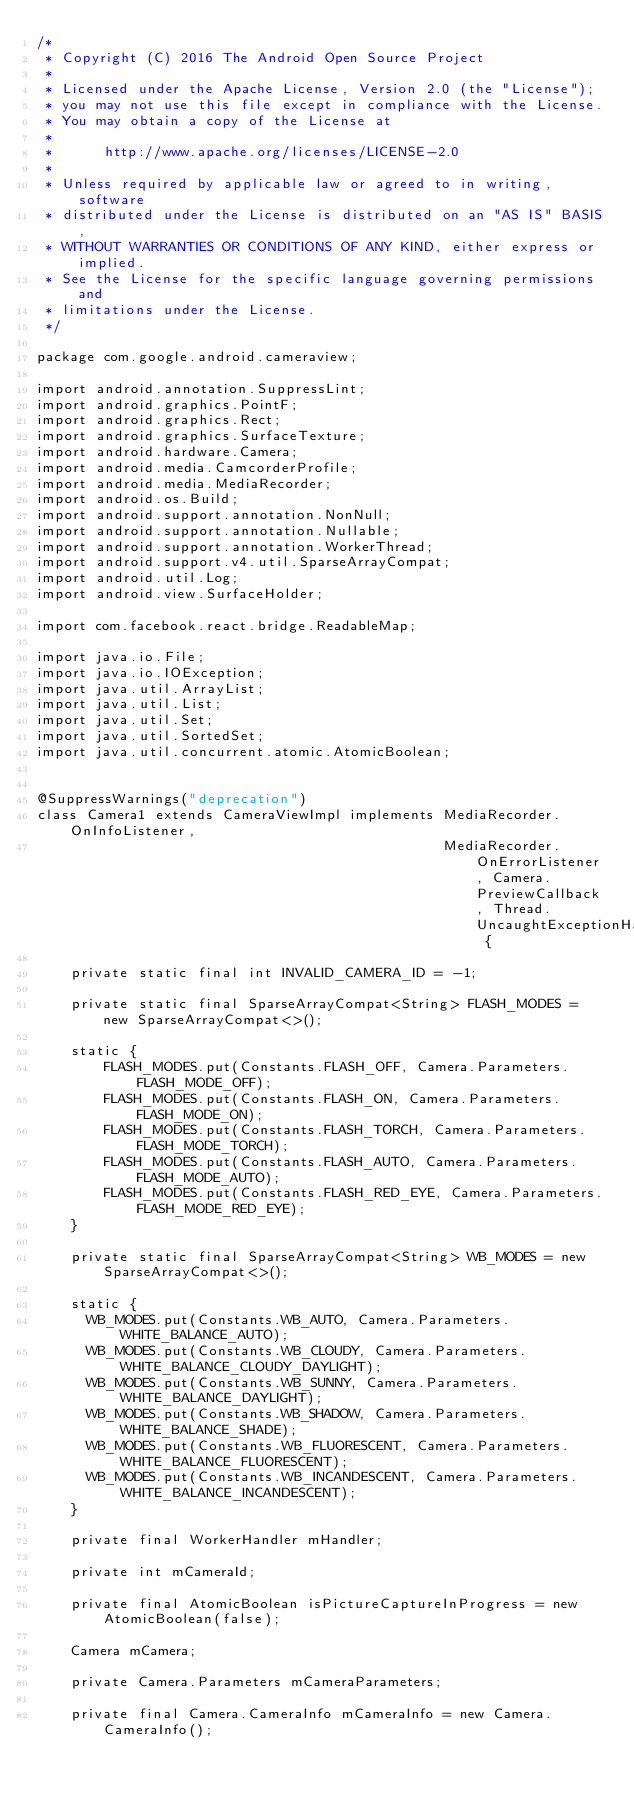<code> <loc_0><loc_0><loc_500><loc_500><_Java_>/*
 * Copyright (C) 2016 The Android Open Source Project
 *
 * Licensed under the Apache License, Version 2.0 (the "License");
 * you may not use this file except in compliance with the License.
 * You may obtain a copy of the License at
 *
 *      http://www.apache.org/licenses/LICENSE-2.0
 *
 * Unless required by applicable law or agreed to in writing, software
 * distributed under the License is distributed on an "AS IS" BASIS,
 * WITHOUT WARRANTIES OR CONDITIONS OF ANY KIND, either express or implied.
 * See the License for the specific language governing permissions and
 * limitations under the License.
 */

package com.google.android.cameraview;

import android.annotation.SuppressLint;
import android.graphics.PointF;
import android.graphics.Rect;
import android.graphics.SurfaceTexture;
import android.hardware.Camera;
import android.media.CamcorderProfile;
import android.media.MediaRecorder;
import android.os.Build;
import android.support.annotation.NonNull;
import android.support.annotation.Nullable;
import android.support.annotation.WorkerThread;
import android.support.v4.util.SparseArrayCompat;
import android.util.Log;
import android.view.SurfaceHolder;

import com.facebook.react.bridge.ReadableMap;

import java.io.File;
import java.io.IOException;
import java.util.ArrayList;
import java.util.List;
import java.util.Set;
import java.util.SortedSet;
import java.util.concurrent.atomic.AtomicBoolean;


@SuppressWarnings("deprecation")
class Camera1 extends CameraViewImpl implements MediaRecorder.OnInfoListener,
                                                MediaRecorder.OnErrorListener, Camera.PreviewCallback, Thread.UncaughtExceptionHandler {

    private static final int INVALID_CAMERA_ID = -1;

    private static final SparseArrayCompat<String> FLASH_MODES = new SparseArrayCompat<>();

    static {
        FLASH_MODES.put(Constants.FLASH_OFF, Camera.Parameters.FLASH_MODE_OFF);
        FLASH_MODES.put(Constants.FLASH_ON, Camera.Parameters.FLASH_MODE_ON);
        FLASH_MODES.put(Constants.FLASH_TORCH, Camera.Parameters.FLASH_MODE_TORCH);
        FLASH_MODES.put(Constants.FLASH_AUTO, Camera.Parameters.FLASH_MODE_AUTO);
        FLASH_MODES.put(Constants.FLASH_RED_EYE, Camera.Parameters.FLASH_MODE_RED_EYE);
    }

    private static final SparseArrayCompat<String> WB_MODES = new SparseArrayCompat<>();

    static {
      WB_MODES.put(Constants.WB_AUTO, Camera.Parameters.WHITE_BALANCE_AUTO);
      WB_MODES.put(Constants.WB_CLOUDY, Camera.Parameters.WHITE_BALANCE_CLOUDY_DAYLIGHT);
      WB_MODES.put(Constants.WB_SUNNY, Camera.Parameters.WHITE_BALANCE_DAYLIGHT);
      WB_MODES.put(Constants.WB_SHADOW, Camera.Parameters.WHITE_BALANCE_SHADE);
      WB_MODES.put(Constants.WB_FLUORESCENT, Camera.Parameters.WHITE_BALANCE_FLUORESCENT);
      WB_MODES.put(Constants.WB_INCANDESCENT, Camera.Parameters.WHITE_BALANCE_INCANDESCENT);
    }

    private final WorkerHandler mHandler;

    private int mCameraId;

    private final AtomicBoolean isPictureCaptureInProgress = new AtomicBoolean(false);

    Camera mCamera;

    private Camera.Parameters mCameraParameters;

    private final Camera.CameraInfo mCameraInfo = new Camera.CameraInfo();
</code> 